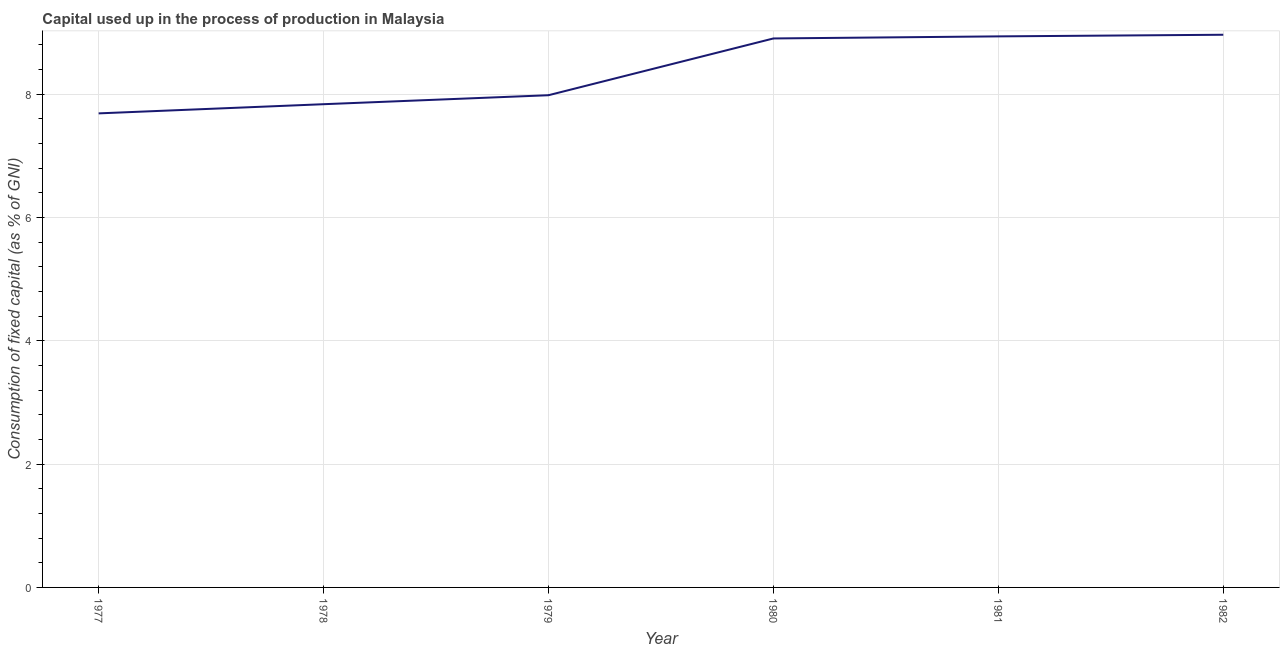What is the consumption of fixed capital in 1981?
Provide a succinct answer. 8.94. Across all years, what is the maximum consumption of fixed capital?
Your answer should be very brief. 8.96. Across all years, what is the minimum consumption of fixed capital?
Keep it short and to the point. 7.69. What is the sum of the consumption of fixed capital?
Give a very brief answer. 50.3. What is the difference between the consumption of fixed capital in 1977 and 1978?
Keep it short and to the point. -0.15. What is the average consumption of fixed capital per year?
Your response must be concise. 8.38. What is the median consumption of fixed capital?
Provide a succinct answer. 8.44. In how many years, is the consumption of fixed capital greater than 5.6 %?
Your answer should be very brief. 6. What is the ratio of the consumption of fixed capital in 1980 to that in 1981?
Provide a short and direct response. 1. Is the difference between the consumption of fixed capital in 1980 and 1981 greater than the difference between any two years?
Provide a succinct answer. No. What is the difference between the highest and the second highest consumption of fixed capital?
Make the answer very short. 0.03. What is the difference between the highest and the lowest consumption of fixed capital?
Give a very brief answer. 1.27. In how many years, is the consumption of fixed capital greater than the average consumption of fixed capital taken over all years?
Offer a terse response. 3. How many lines are there?
Ensure brevity in your answer.  1. What is the title of the graph?
Offer a terse response. Capital used up in the process of production in Malaysia. What is the label or title of the X-axis?
Offer a very short reply. Year. What is the label or title of the Y-axis?
Provide a succinct answer. Consumption of fixed capital (as % of GNI). What is the Consumption of fixed capital (as % of GNI) in 1977?
Your response must be concise. 7.69. What is the Consumption of fixed capital (as % of GNI) in 1978?
Provide a succinct answer. 7.84. What is the Consumption of fixed capital (as % of GNI) of 1979?
Provide a short and direct response. 7.98. What is the Consumption of fixed capital (as % of GNI) of 1980?
Your answer should be compact. 8.9. What is the Consumption of fixed capital (as % of GNI) in 1981?
Provide a succinct answer. 8.94. What is the Consumption of fixed capital (as % of GNI) in 1982?
Offer a terse response. 8.96. What is the difference between the Consumption of fixed capital (as % of GNI) in 1977 and 1978?
Give a very brief answer. -0.15. What is the difference between the Consumption of fixed capital (as % of GNI) in 1977 and 1979?
Ensure brevity in your answer.  -0.29. What is the difference between the Consumption of fixed capital (as % of GNI) in 1977 and 1980?
Your answer should be very brief. -1.21. What is the difference between the Consumption of fixed capital (as % of GNI) in 1977 and 1981?
Keep it short and to the point. -1.25. What is the difference between the Consumption of fixed capital (as % of GNI) in 1977 and 1982?
Offer a terse response. -1.27. What is the difference between the Consumption of fixed capital (as % of GNI) in 1978 and 1979?
Your answer should be very brief. -0.15. What is the difference between the Consumption of fixed capital (as % of GNI) in 1978 and 1980?
Make the answer very short. -1.07. What is the difference between the Consumption of fixed capital (as % of GNI) in 1978 and 1981?
Keep it short and to the point. -1.1. What is the difference between the Consumption of fixed capital (as % of GNI) in 1978 and 1982?
Provide a succinct answer. -1.13. What is the difference between the Consumption of fixed capital (as % of GNI) in 1979 and 1980?
Provide a succinct answer. -0.92. What is the difference between the Consumption of fixed capital (as % of GNI) in 1979 and 1981?
Keep it short and to the point. -0.95. What is the difference between the Consumption of fixed capital (as % of GNI) in 1979 and 1982?
Offer a terse response. -0.98. What is the difference between the Consumption of fixed capital (as % of GNI) in 1980 and 1981?
Offer a very short reply. -0.03. What is the difference between the Consumption of fixed capital (as % of GNI) in 1980 and 1982?
Your response must be concise. -0.06. What is the difference between the Consumption of fixed capital (as % of GNI) in 1981 and 1982?
Your answer should be very brief. -0.03. What is the ratio of the Consumption of fixed capital (as % of GNI) in 1977 to that in 1980?
Offer a terse response. 0.86. What is the ratio of the Consumption of fixed capital (as % of GNI) in 1977 to that in 1981?
Keep it short and to the point. 0.86. What is the ratio of the Consumption of fixed capital (as % of GNI) in 1977 to that in 1982?
Give a very brief answer. 0.86. What is the ratio of the Consumption of fixed capital (as % of GNI) in 1978 to that in 1979?
Offer a terse response. 0.98. What is the ratio of the Consumption of fixed capital (as % of GNI) in 1978 to that in 1981?
Offer a very short reply. 0.88. What is the ratio of the Consumption of fixed capital (as % of GNI) in 1978 to that in 1982?
Provide a short and direct response. 0.87. What is the ratio of the Consumption of fixed capital (as % of GNI) in 1979 to that in 1980?
Give a very brief answer. 0.9. What is the ratio of the Consumption of fixed capital (as % of GNI) in 1979 to that in 1981?
Your response must be concise. 0.89. What is the ratio of the Consumption of fixed capital (as % of GNI) in 1979 to that in 1982?
Offer a very short reply. 0.89. 